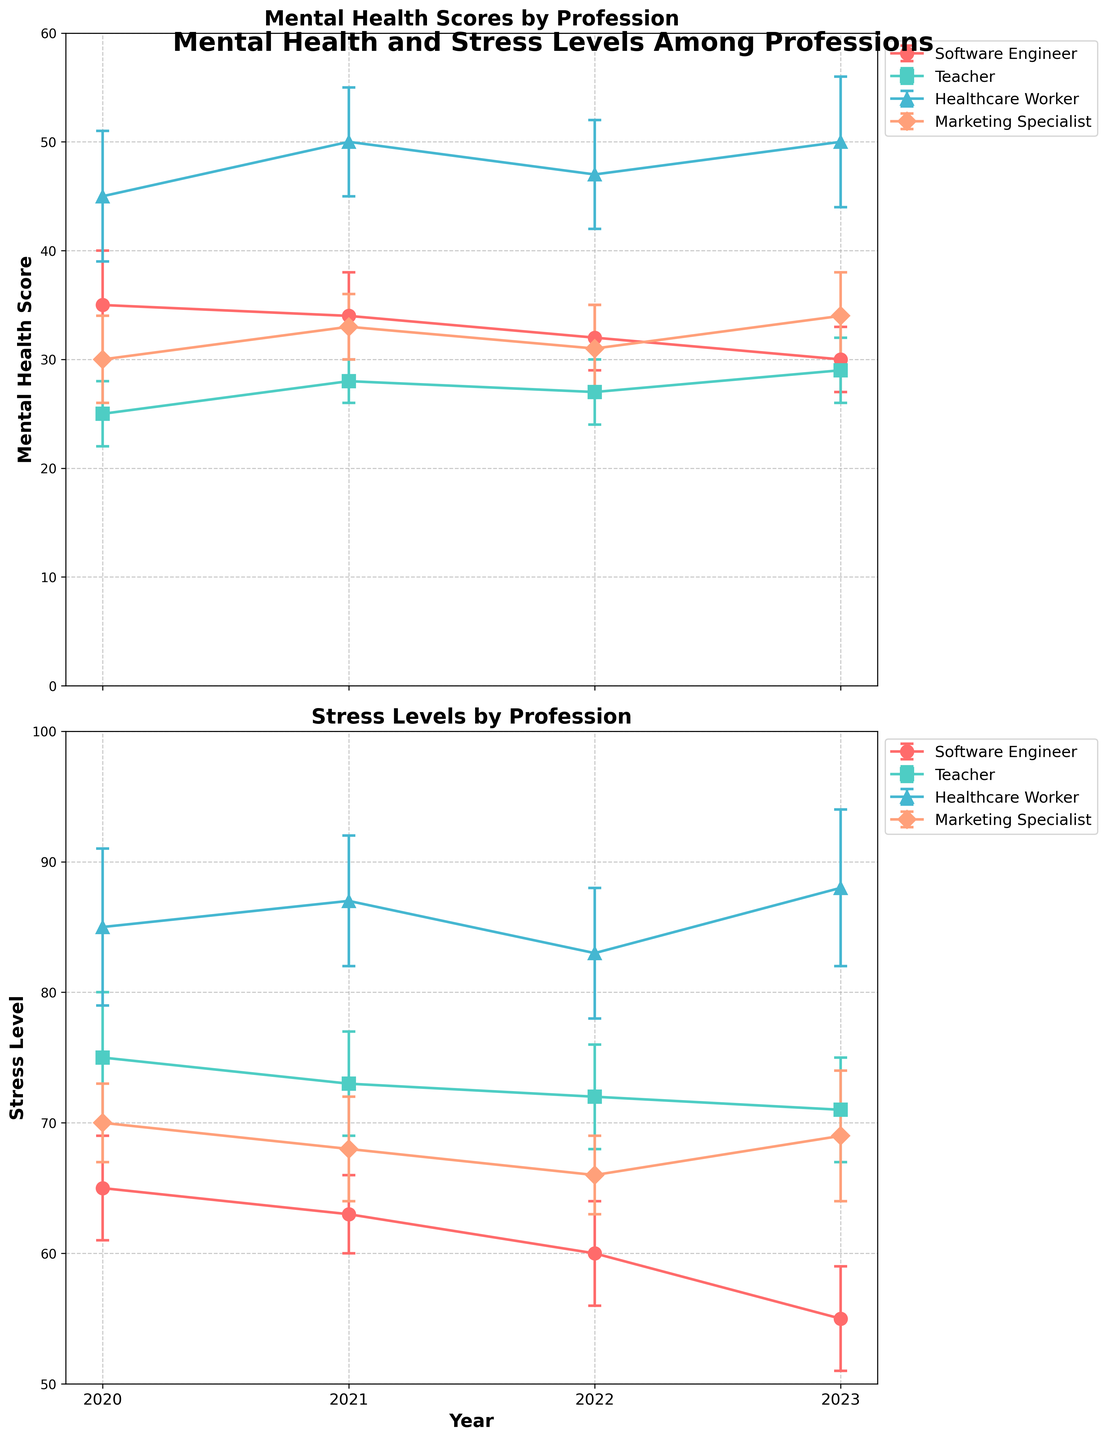What is the title of the figure? The title of the figure is at the top and reads, "Mental Health and Stress Levels Among Professions".
Answer: Mental Health and Stress Levels Among Professions Which profession had the highest mental health score in 2023? To find this, look at the 2023 data points on the mental health subplot. The highest point corresponds to Healthcare Worker.
Answer: Healthcare Worker How did the mental health score for Software Engineers change from 2020 to 2023? Trace the mental health scores for Software Engineers from 2020 to 2023 on the mental health score subplot. Scores are 35 in 2020, 34 in 2021, 32 in 2022, and 30 in 2023.
Answer: Decreased Which year shows the lowest stress level for Teachers? Look at the stress level subplot and find the lowest point for Teachers. The lowest stress level for Teachers is in 2023.
Answer: 2023 Compare the mental health score trends for Marketing Specialists and Teachers from 2020 to 2023. Which profession showed improvement? Observe the trends in the mental health scores for both professions. Marketing Specialists show a gradual increase from 30 in 2020 to 34 in 2023, while Teachers remain relatively flat around 25-29.
Answer: Marketing Specialists What was the stress level difference between Healthcare Workers and Software Engineers in 2021? Find the stress levels for both professions in 2021 on the stress level subplot. Healthcare Workers: 87, Software Engineers: 63. Then, calculate the difference: 87 - 63.
Answer: 24 How do the error margins for mental health scores compare among professions in 2022? Analyze the error bars on the mental health subplot for the year 2022. Compare the lengths of the error bars. Healthcare Workers have the largest, followed by Marketing Specialists, Teachers, and Software Engineers.
Answer: Healthcare Workers > Marketing Specialists > Teachers > Software Engineers Identify the year with the most significant improvement in the mental health score for Healthcare Workers. Check the changes in mental health scores over the years for Healthcare Workers. From 2020 to 2021, the score increases from 45 to 50, which is the largest improvement.
Answer: 2021 Do any professions show a contradictory trend between their mental health scores and stress levels from 2020 to 2023? Compare the mental health score and stress level trends for each profession. For example, Healthcare Workers have increasing health scores and stress levels, which might be seen as contradictory.
Answer: Healthcare Workers 